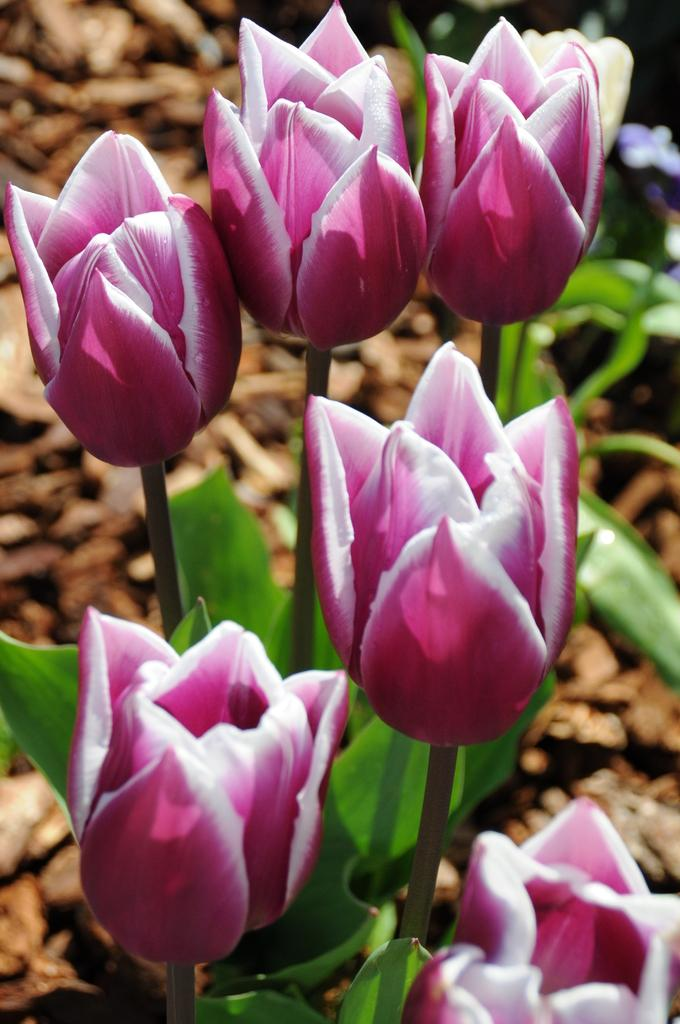What type of living organisms are present in the image? There are plants in the image. What color are the flowers on the plants? The flowers on the plants are pink. What color are the leaves on the plants? The leaves on the plants are green. How would you describe the background of the image? The background of the image is blurred. What type of comb is used to style the plants in the image? There is no comb present in the image, and plants do not require styling. 